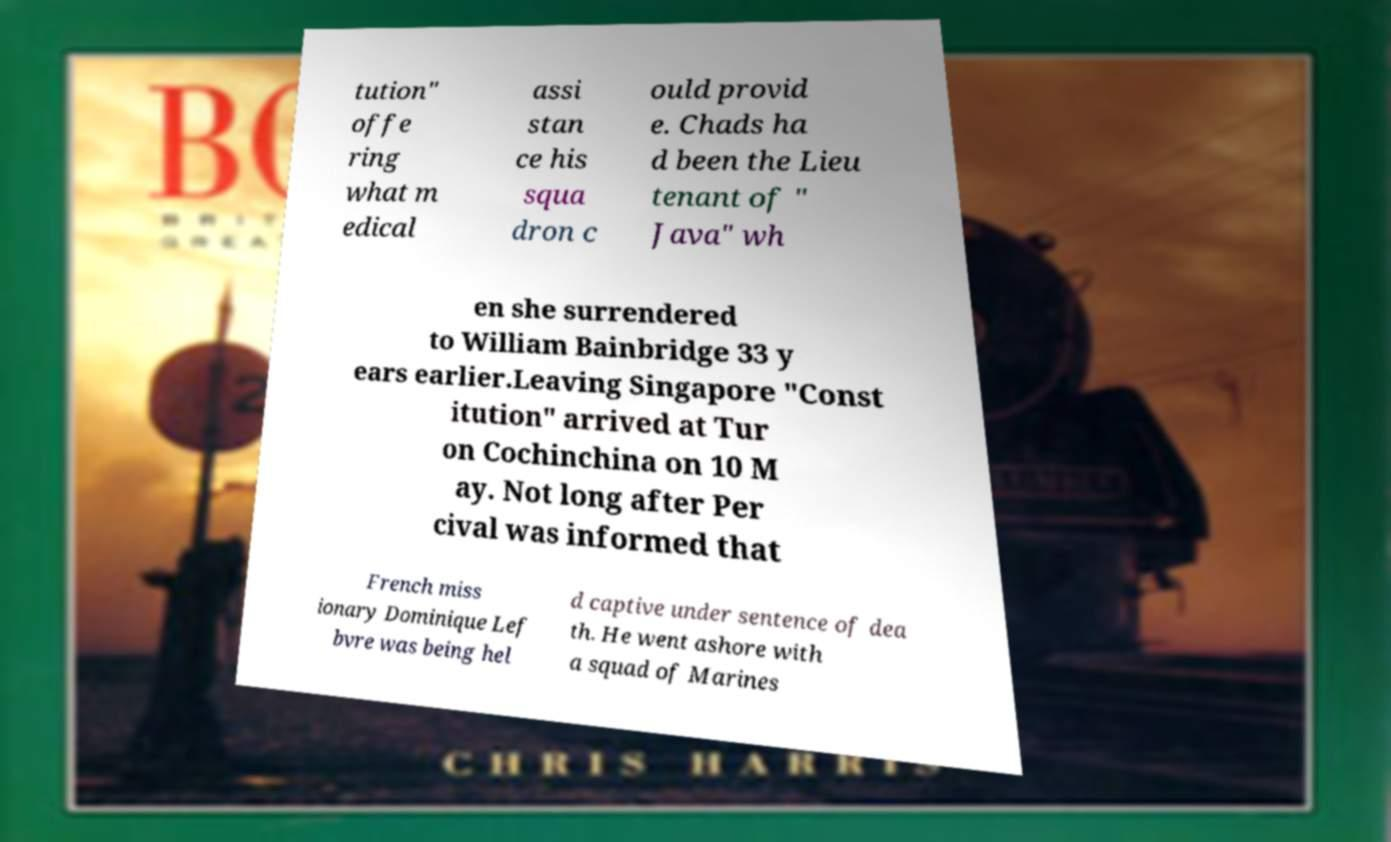What messages or text are displayed in this image? I need them in a readable, typed format. tution" offe ring what m edical assi stan ce his squa dron c ould provid e. Chads ha d been the Lieu tenant of " Java" wh en she surrendered to William Bainbridge 33 y ears earlier.Leaving Singapore "Const itution" arrived at Tur on Cochinchina on 10 M ay. Not long after Per cival was informed that French miss ionary Dominique Lef bvre was being hel d captive under sentence of dea th. He went ashore with a squad of Marines 